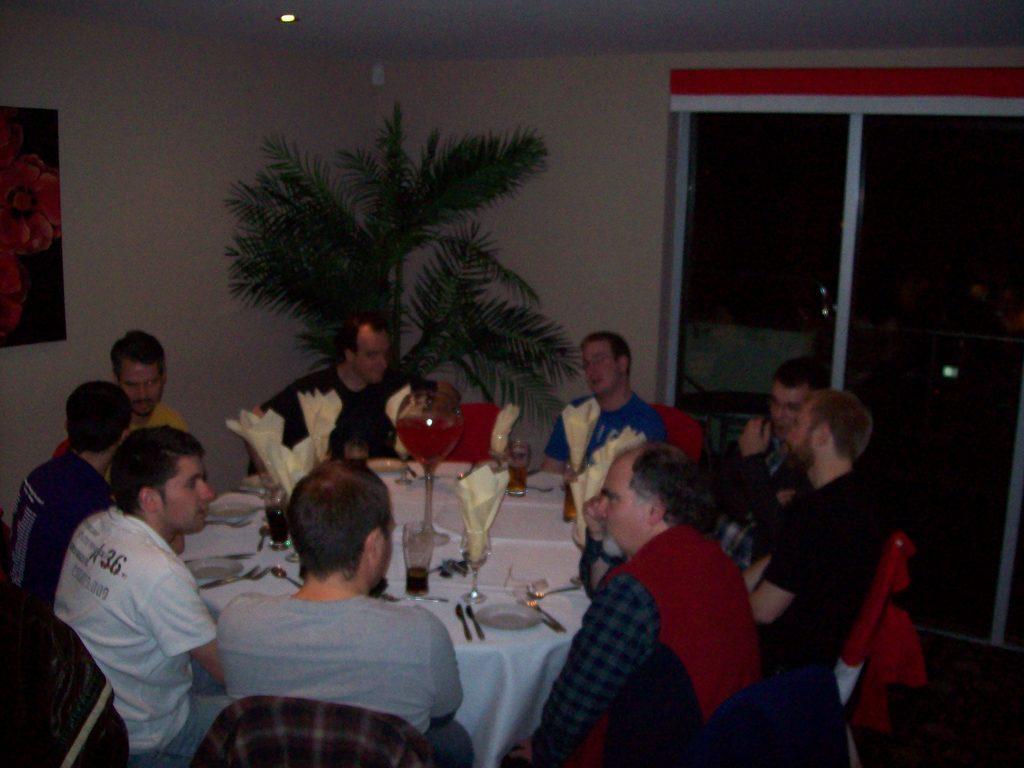In one or two sentences, can you explain what this image depicts? In this image i can see a group of people sitting on the chair there are few glasses, spoons on a table at the back ground i can see a tree, at left there is a frame attached to a wall, on the frame there is a red color , at right there is a glass door, at the top there is a light. 